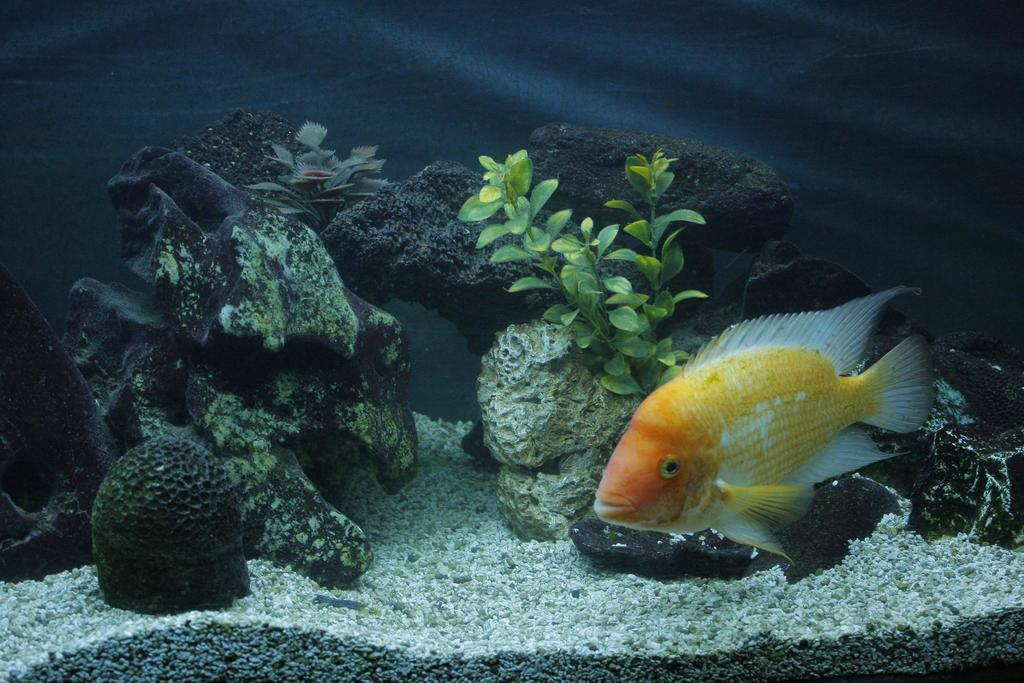Where was the image taken? The image was taken in an aquarium. What can be seen in the bottom right of the image? There is a fish in the bottom right of the image. What colors does the fish have? The fish is orange and white in color. What is behind the fish in the image? There are stones and plants behind the fish. What type of bird can be seen perched on the edge of the aquarium in the image? There is no bird visible in the image; it is focused on a fish in an aquarium setting. 